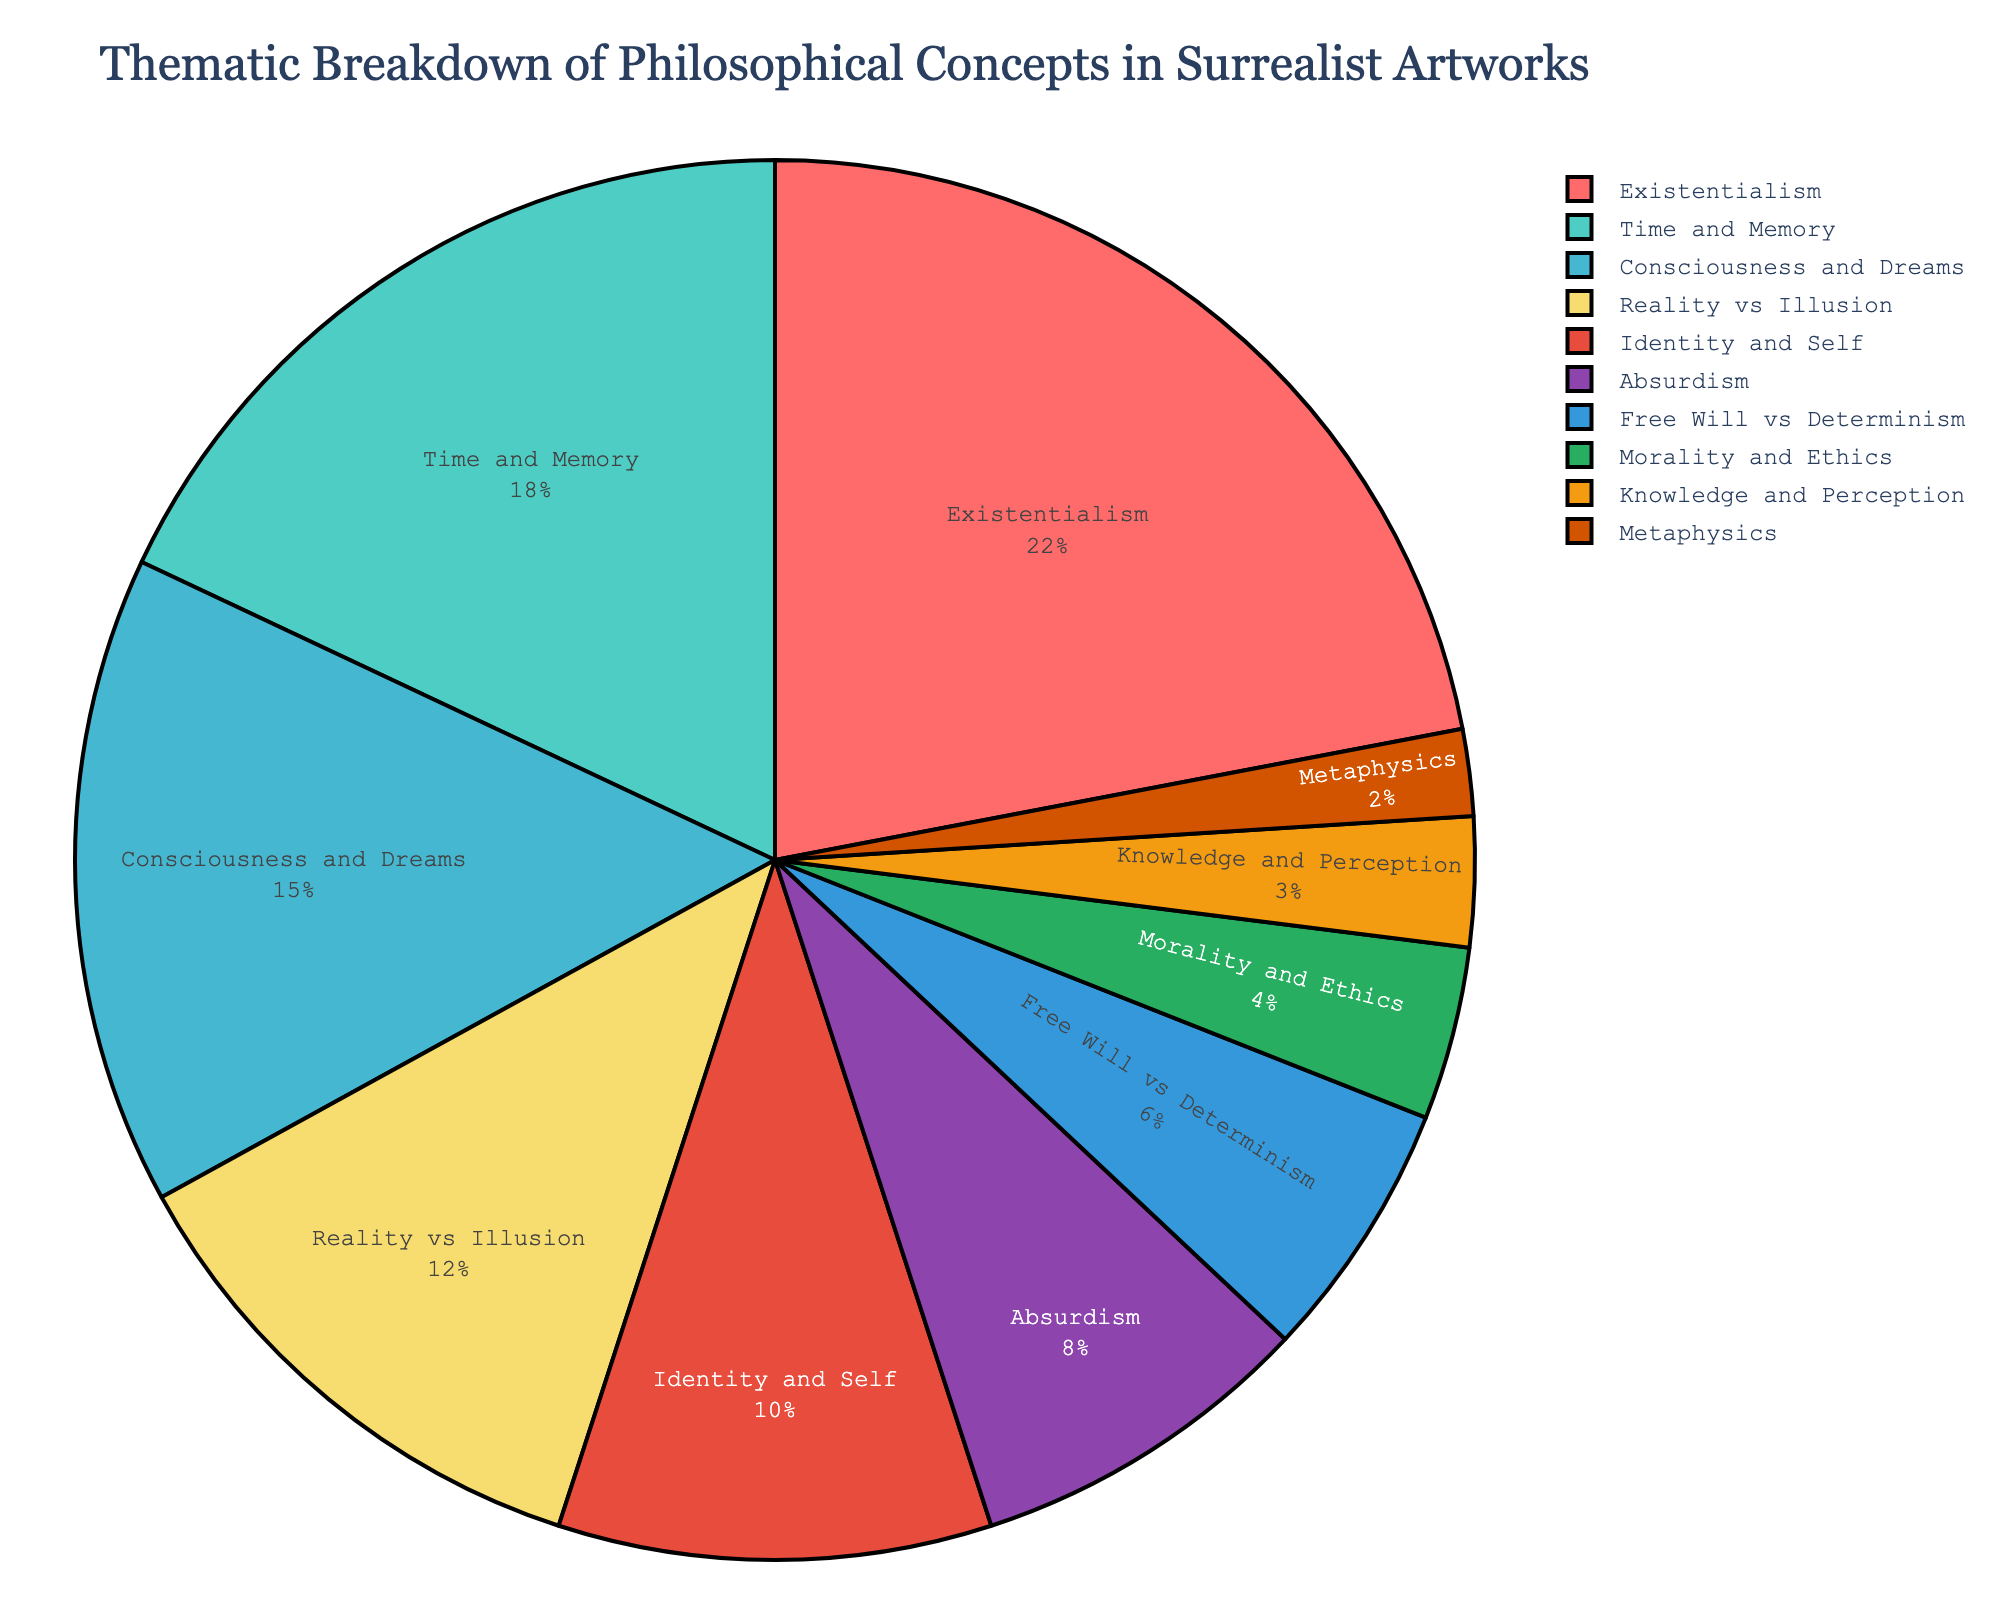Which philosophical concept is covered the most in surrealist artworks? The pie chart shows different percentages for each philosophical concept, with "Existentialism" having the highest percentage at 22%.
Answer: Existentialism What percentage of the chart is covered by themes related to the self (Identity and Self, Free Will vs Determinism, Consciousness and Dreams)? We need to sum the percentages for "Identity and Self" (10%), "Free Will vs Determinism" (6%), and "Consciousness and Dreams" (15%). The total is 10 + 6 + 15 = 31%.
Answer: 31% Which theme has a higher percentage: Absurdism or Reality vs Illusion? By looking at the chart, we can see that "Reality vs Illusion" is at 12% and "Absurdism" is at 8%. 12% is greater than 8%.
Answer: Reality vs Illusion What is the combined percentage of Time and Memory and Morality and Ethics? Adding the percentages for "Time and Memory" (18%) and "Morality and Ethics" (4%) gives 18 + 4 = 22%.
Answer: 22% How does the percentage of Metaphysics compare to that of Knowledge and Perception? The pie chart shows "Metaphysics" at 2% and "Knowledge and Perception" at 3%. 2% is less than 3%.
Answer: Less Which themes make up less than 10% of the chart? Examining the chart reveals that "Absurdism" (8%), "Free Will vs Determinism" (6%), "Morality and Ethics" (4%), "Knowledge and Perception" (3%), and "Metaphysics" (2%) are all less than 10%.
Answer: Absurdism, Free Will vs Determinism, Morality and Ethics, Knowledge and Perception, Metaphysics What is the second most common theme explored in surrealist artworks? The pie chart shows that after "Existentialism" (22%), "Time and Memory" has the second-highest percentage at 18%.
Answer: Time and Memory If you combined the percentages of Reality vs Illusion, Identity and Self, and Absurdism, what would the total be? Adding the percentages for "Reality vs Illusion" (12%), "Identity and Self" (10%), and "Absurdism" (8%) gives 12 + 10 + 8 = 30%.
Answer: 30% What themes share the same color, and what color is it? Visual inspection of the pie chart shows that each theme has a unique color, so no themes share the same color.
Answer: None By how much does the percentage of Existentialism exceed that of Consciousness and Dreams? The percentage for "Existentialism" is 22%, and "Consciousness and Dreams" is 15%. The difference is 22 - 15 = 7%.
Answer: 7% 